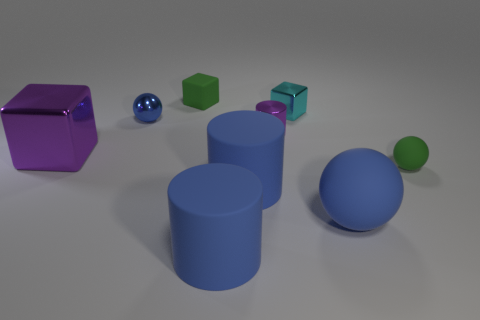There is a large object that is made of the same material as the small cyan cube; what is its shape? cube 